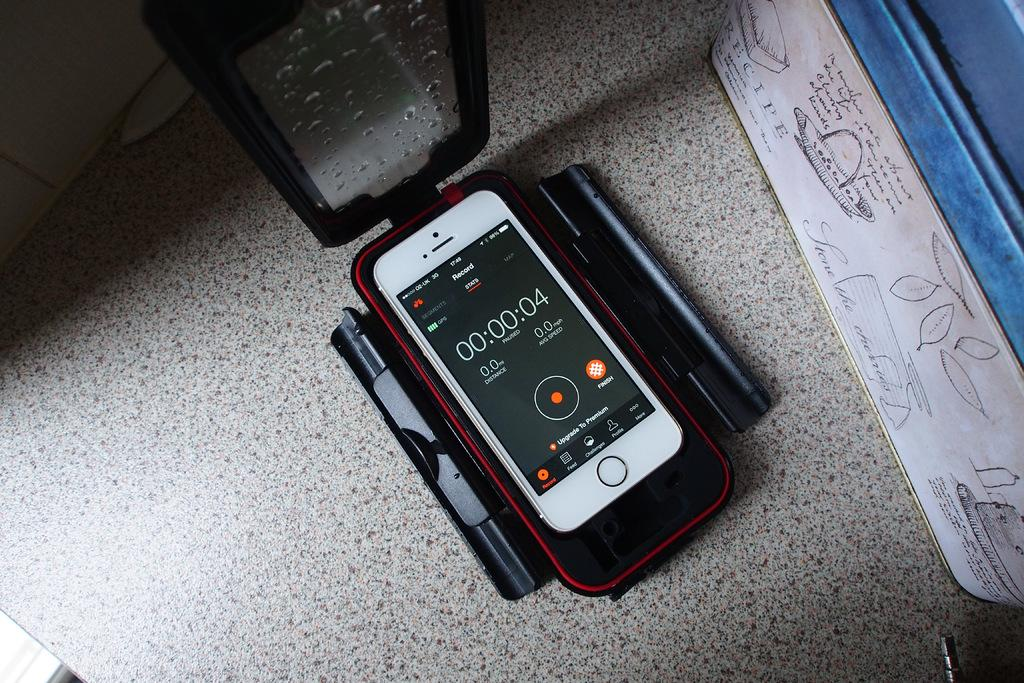<image>
Relay a brief, clear account of the picture shown. A cellphone sits in a case of some kind with the Record function displayed. 